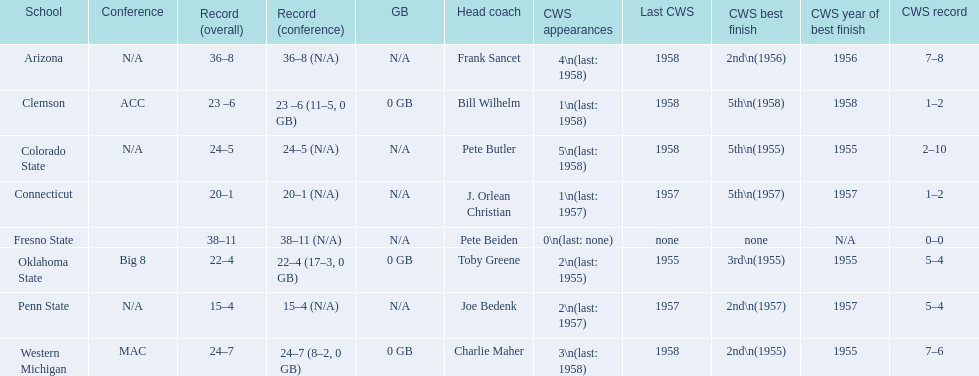How many teams had their cws best finish in 1955? 3. 